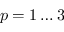<formula> <loc_0><loc_0><loc_500><loc_500>p = 1 \dots 3</formula> 